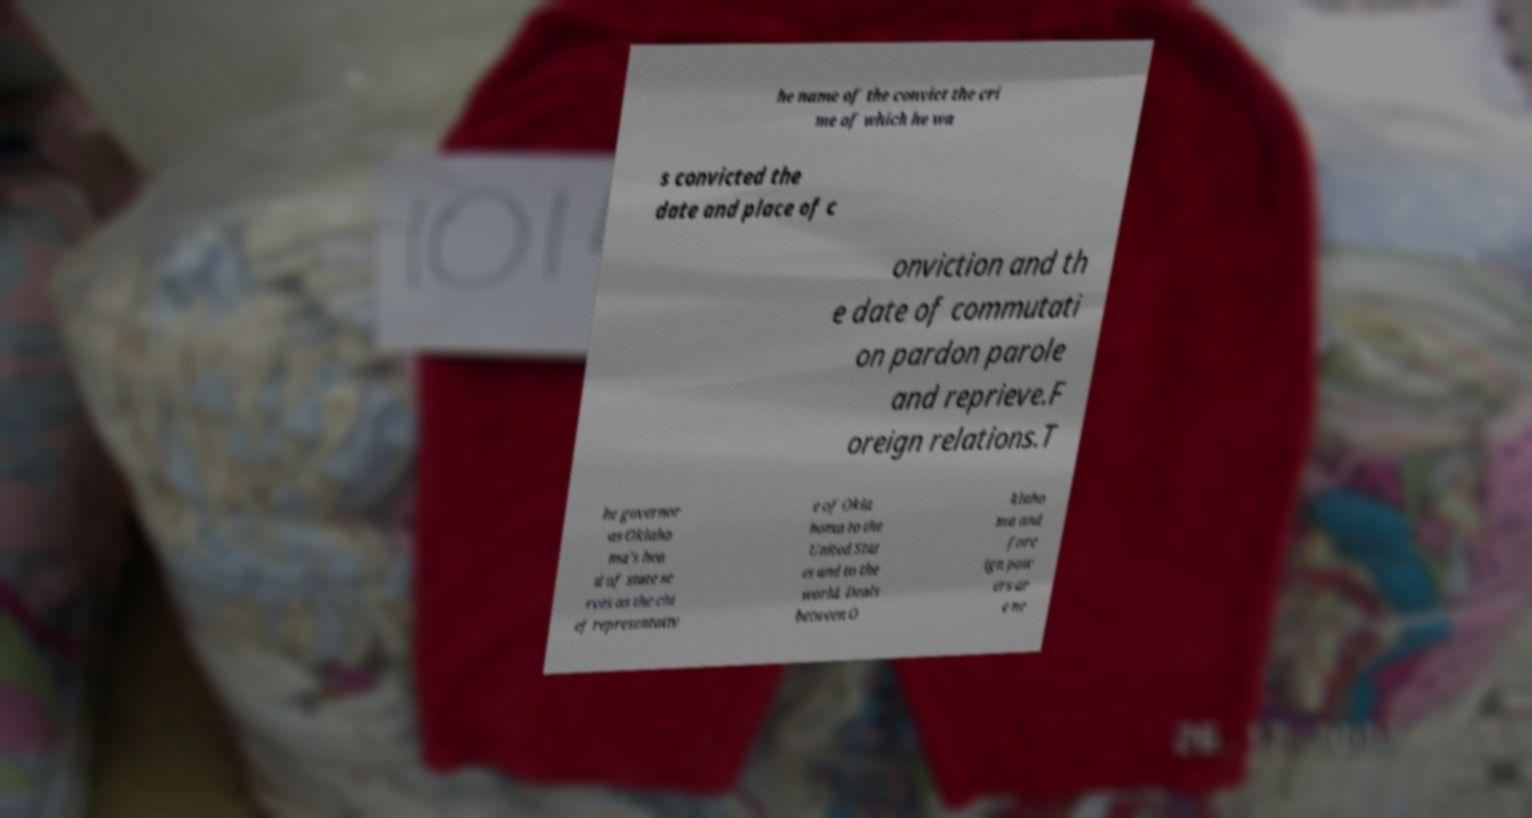There's text embedded in this image that I need extracted. Can you transcribe it verbatim? he name of the convict the cri me of which he wa s convicted the date and place of c onviction and th e date of commutati on pardon parole and reprieve.F oreign relations.T he governor as Oklaho ma's hea d of state se rves as the chi ef representativ e of Okla homa to the United Stat es and to the world. Deals between O klaho ma and fore ign pow ers ar e ne 